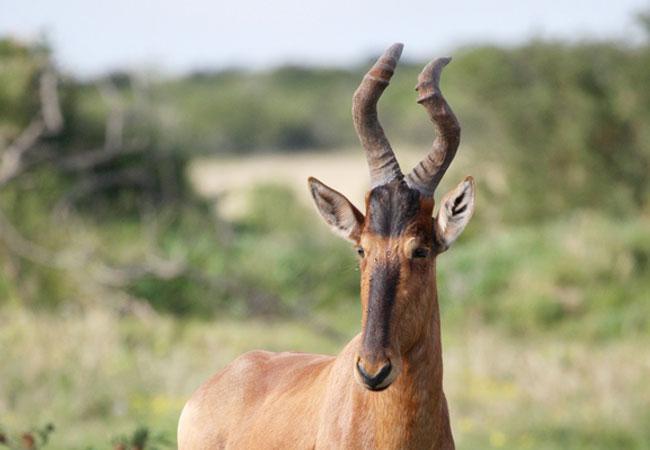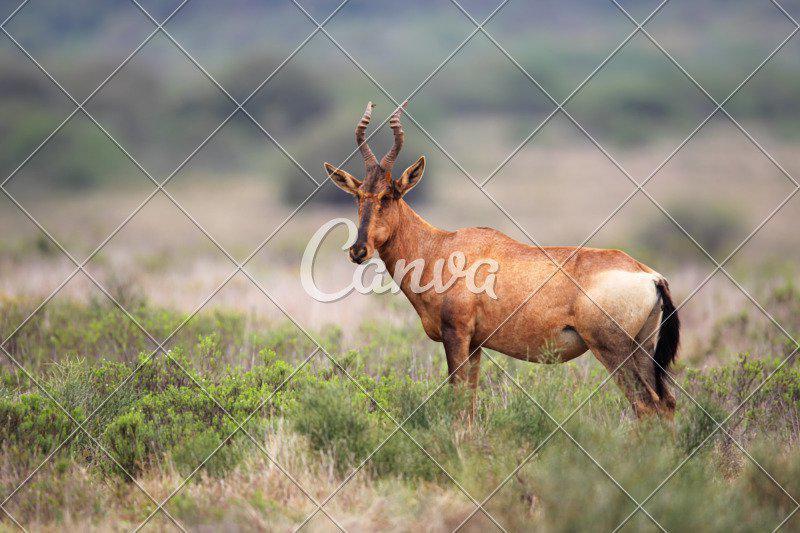The first image is the image on the left, the second image is the image on the right. Considering the images on both sides, is "Exactly one animal is pointed left." valid? Answer yes or no. Yes. The first image is the image on the left, the second image is the image on the right. Examine the images to the left and right. Is the description "Each image contains only one horned animal, and the animal in the right image stands in profile turned leftward." accurate? Answer yes or no. Yes. 